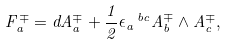Convert formula to latex. <formula><loc_0><loc_0><loc_500><loc_500>F _ { a } ^ { \mp } = d A _ { a } ^ { \mp } + { \frac { 1 } { 2 } } \epsilon _ { a } \, ^ { b c } A _ { b } ^ { \mp } \wedge A _ { c } ^ { \mp } ,</formula> 